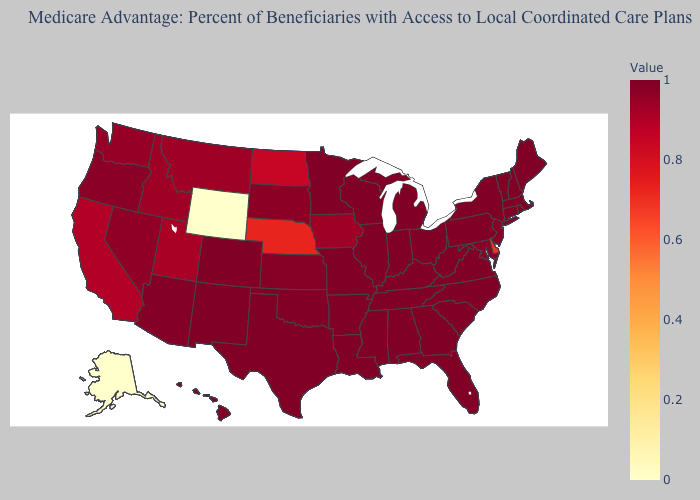Which states have the lowest value in the USA?
Be succinct. Alaska, Wyoming. Does Virginia have the lowest value in the USA?
Concise answer only. No. Which states have the highest value in the USA?
Write a very short answer. Connecticut, Florida, Georgia, Hawaii, Illinois, Indiana, Kentucky, Louisiana, Massachusetts, Maine, Michigan, Minnesota, Missouri, Mississippi, North Carolina, New Hampshire, New Mexico, New York, Ohio, Pennsylvania, Rhode Island, South Carolina, Tennessee, Texas, Virginia, Vermont, Wisconsin, West Virginia, Alabama, Arkansas. Does Arkansas have the highest value in the USA?
Quick response, please. Yes. Among the states that border New Jersey , does Pennsylvania have the lowest value?
Be succinct. No. 